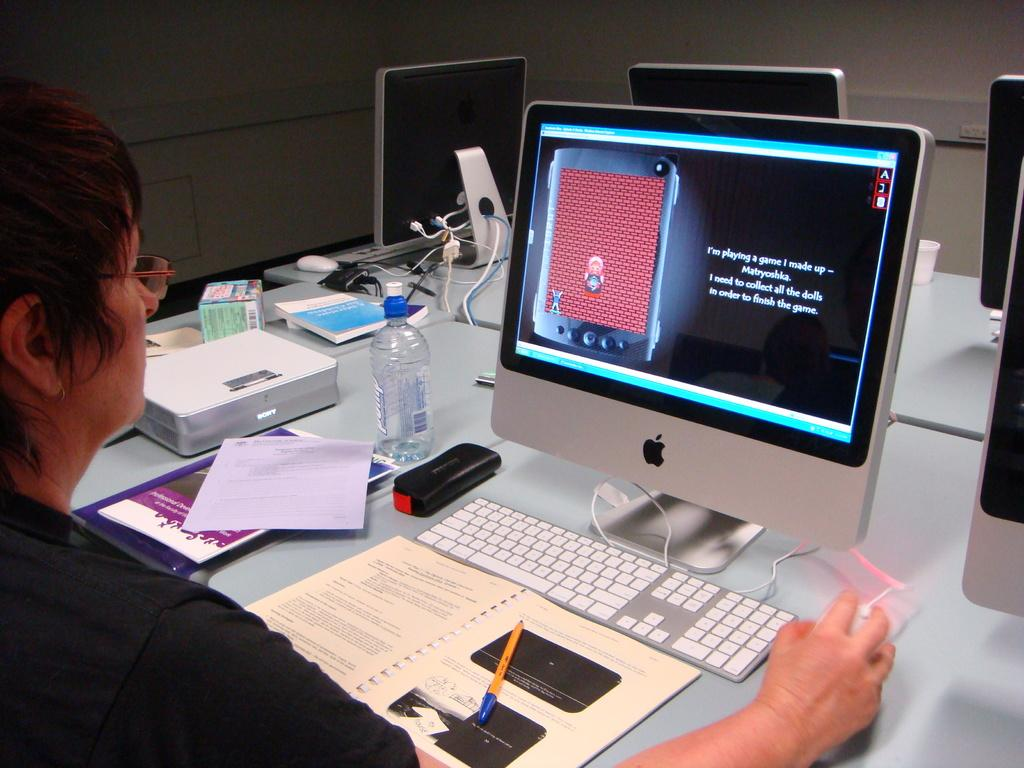Provide a one-sentence caption for the provided image. A woman is playing a game on a computer and she needs to collect all the dolls to finish the game. 